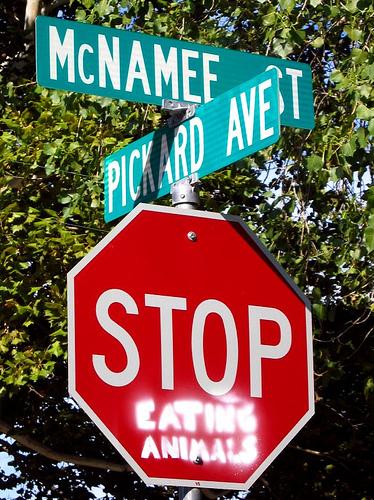What is written under the stop sign?
Quick response, please. Eating animals. What color is the stop sign?
Keep it brief. Red. What word is written under the word stop?
Concise answer only. Eating animals. How many street names are shown?
Quick response, please. 2. What does it say under the stop sign?
Concise answer only. Eating animals. What are the streets running through this intersection?
Short answer required. Mcnamee and pickard. 